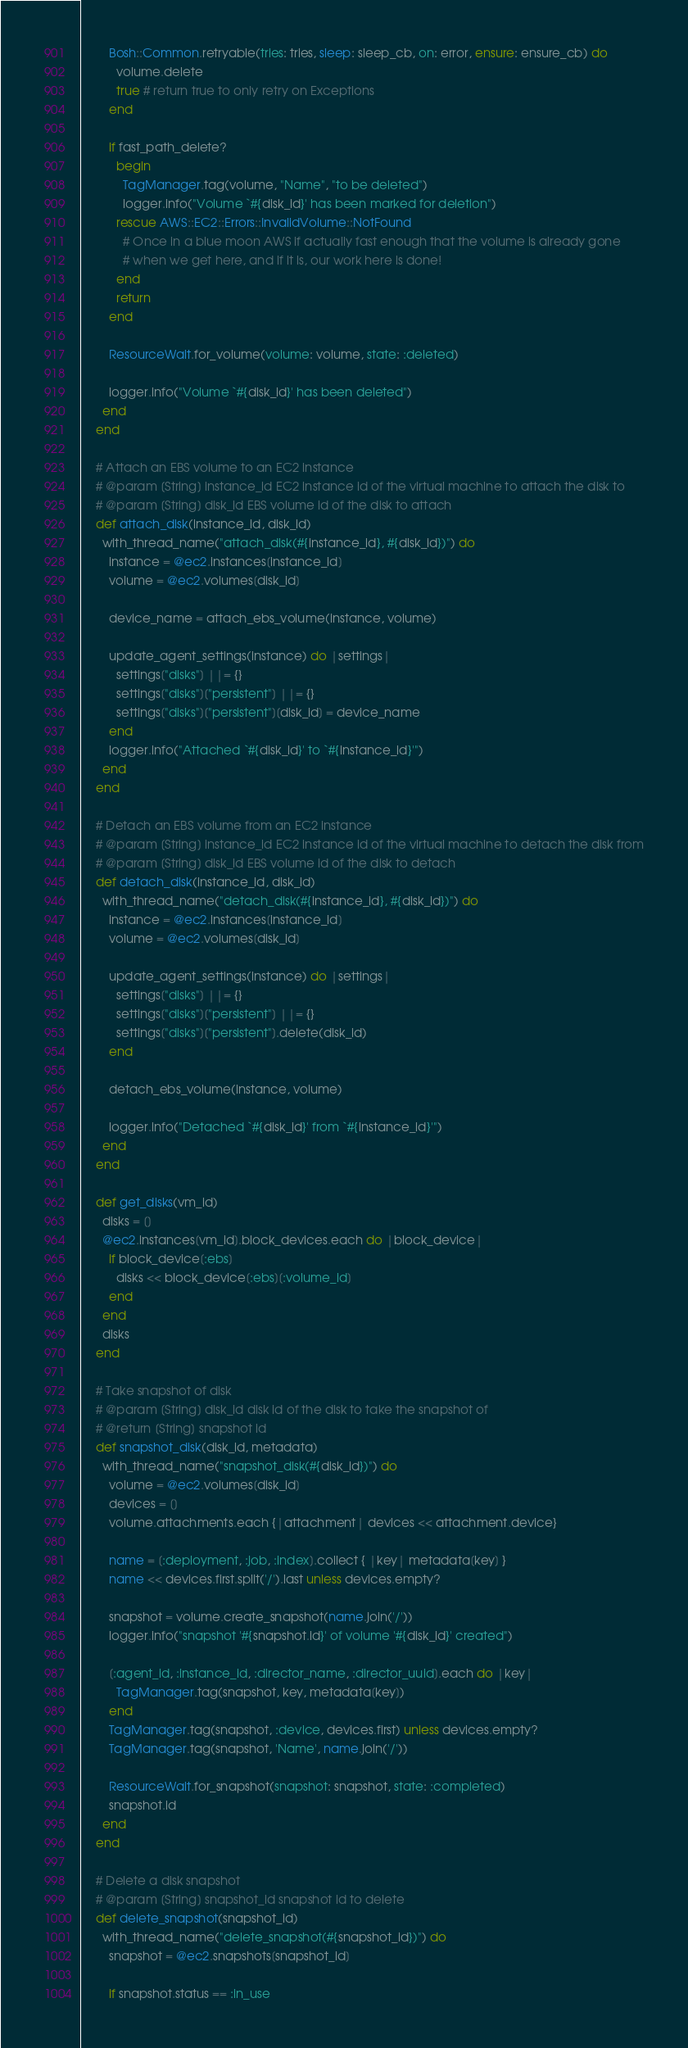<code> <loc_0><loc_0><loc_500><loc_500><_Ruby_>
        Bosh::Common.retryable(tries: tries, sleep: sleep_cb, on: error, ensure: ensure_cb) do
          volume.delete
          true # return true to only retry on Exceptions
        end

        if fast_path_delete?
          begin
            TagManager.tag(volume, "Name", "to be deleted")
            logger.info("Volume `#{disk_id}' has been marked for deletion")
          rescue AWS::EC2::Errors::InvalidVolume::NotFound
            # Once in a blue moon AWS if actually fast enough that the volume is already gone
            # when we get here, and if it is, our work here is done!
          end
          return
        end

        ResourceWait.for_volume(volume: volume, state: :deleted)

        logger.info("Volume `#{disk_id}' has been deleted")
      end
    end

    # Attach an EBS volume to an EC2 instance
    # @param [String] instance_id EC2 instance id of the virtual machine to attach the disk to
    # @param [String] disk_id EBS volume id of the disk to attach
    def attach_disk(instance_id, disk_id)
      with_thread_name("attach_disk(#{instance_id}, #{disk_id})") do
        instance = @ec2.instances[instance_id]
        volume = @ec2.volumes[disk_id]

        device_name = attach_ebs_volume(instance, volume)

        update_agent_settings(instance) do |settings|
          settings["disks"] ||= {}
          settings["disks"]["persistent"] ||= {}
          settings["disks"]["persistent"][disk_id] = device_name
        end
        logger.info("Attached `#{disk_id}' to `#{instance_id}'")
      end
    end

    # Detach an EBS volume from an EC2 instance
    # @param [String] instance_id EC2 instance id of the virtual machine to detach the disk from
    # @param [String] disk_id EBS volume id of the disk to detach
    def detach_disk(instance_id, disk_id)
      with_thread_name("detach_disk(#{instance_id}, #{disk_id})") do
        instance = @ec2.instances[instance_id]
        volume = @ec2.volumes[disk_id]

        update_agent_settings(instance) do |settings|
          settings["disks"] ||= {}
          settings["disks"]["persistent"] ||= {}
          settings["disks"]["persistent"].delete(disk_id)
        end

        detach_ebs_volume(instance, volume)

        logger.info("Detached `#{disk_id}' from `#{instance_id}'")
      end
    end

    def get_disks(vm_id)
      disks = []
      @ec2.instances[vm_id].block_devices.each do |block_device|
        if block_device[:ebs]
          disks << block_device[:ebs][:volume_id]
        end
      end
      disks
    end

    # Take snapshot of disk
    # @param [String] disk_id disk id of the disk to take the snapshot of
    # @return [String] snapshot id
    def snapshot_disk(disk_id, metadata)
      with_thread_name("snapshot_disk(#{disk_id})") do
        volume = @ec2.volumes[disk_id]
        devices = []
        volume.attachments.each {|attachment| devices << attachment.device}

        name = [:deployment, :job, :index].collect { |key| metadata[key] }
        name << devices.first.split('/').last unless devices.empty?

        snapshot = volume.create_snapshot(name.join('/'))
        logger.info("snapshot '#{snapshot.id}' of volume '#{disk_id}' created")

        [:agent_id, :instance_id, :director_name, :director_uuid].each do |key|
          TagManager.tag(snapshot, key, metadata[key])
        end
        TagManager.tag(snapshot, :device, devices.first) unless devices.empty?
        TagManager.tag(snapshot, 'Name', name.join('/'))

        ResourceWait.for_snapshot(snapshot: snapshot, state: :completed)
        snapshot.id
      end
    end

    # Delete a disk snapshot
    # @param [String] snapshot_id snapshot id to delete
    def delete_snapshot(snapshot_id)
      with_thread_name("delete_snapshot(#{snapshot_id})") do
        snapshot = @ec2.snapshots[snapshot_id]

        if snapshot.status == :in_use</code> 